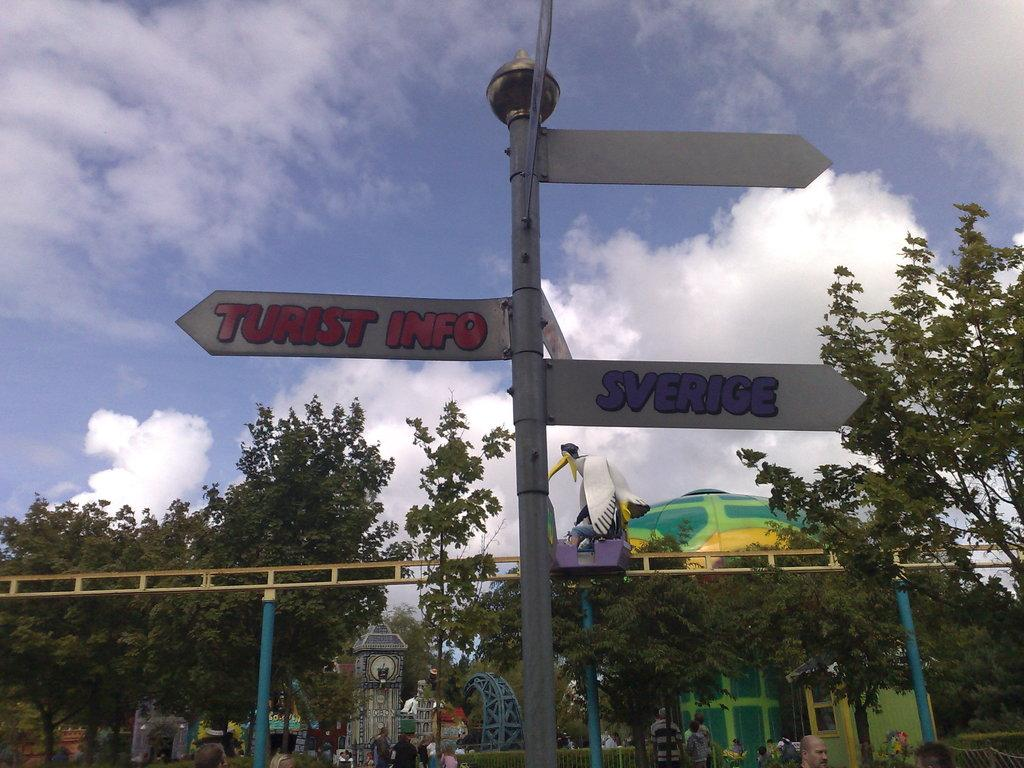What type of natural elements can be seen in the image? There are trees in the image. What man-made structures are present in the image? There are poles, boards, a fence, a house, and a tower in the image. Are there any people in the image? Yes, there are people in the image. What type of recreational objects can be seen in the image? There are playing objects in the image. What is visible in the background of the image? The sky is visible in the background of the image. Can you tell me how many steam engines are present in the image? There are no steam engines present in the image. What type of scientific equipment can be seen in the image? There is no scientific equipment present in the image. 